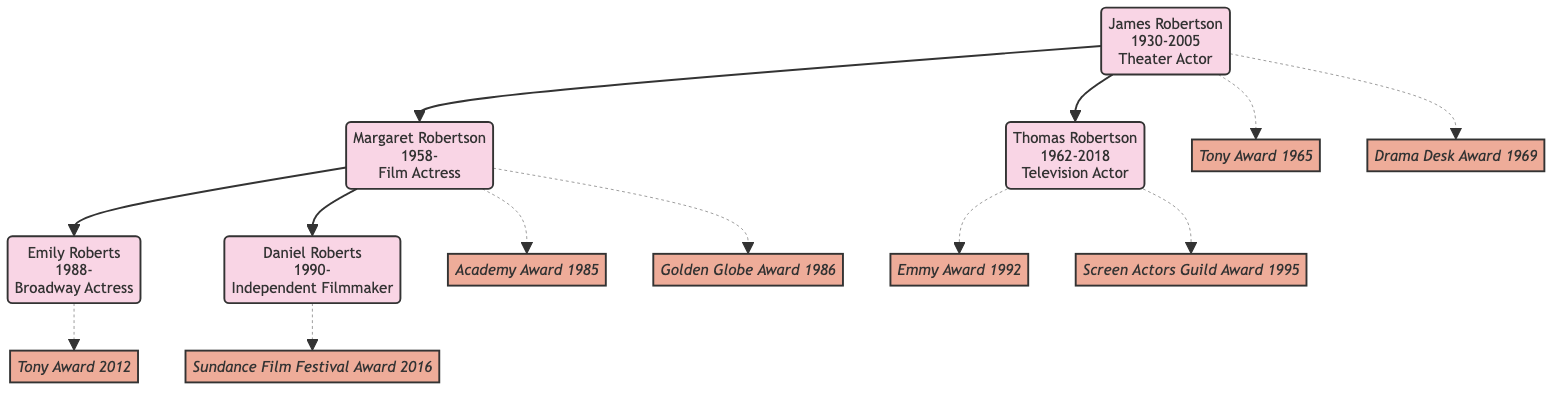What is the profession of James Robertson? The diagram shows that James Robertson is labeled as a "Theater Actor." Therefore, we look at his node to find this information directly.
Answer: Theater Actor How many children does James Robertson have? By examining the children nodes connected to James Robertson, we see there are two children: Margaret Robertson and Thomas Robertson. Thus, the count is two.
Answer: 2 What award did Thomas Robertson win in 1992? The diagram shows that Thomas Robertson won the "Emmy Award for Outstanding Lead Actor" in 1992, which is directly linked to his node as an award he received.
Answer: Emmy Award for Outstanding Lead Actor Which grandchild is a Broadway Actress? Emily Roberts' node clearly states that she is a "Broadway Actress." By locating her node among the grandchildren, we find this information directly.
Answer: Emily Roberts Who is the independent filmmaker in the family? The diagram identifies Daniel Roberts as the "Independent Filmmaker," associated with his node. Thus, he is the individual fulfilling this role in the family tree.
Answer: Daniel Roberts Which parent's performance awards are the most? We compare the number of awards listed for James Robertson, Margaret Robertson, and Thomas Robertson. James has two, Margaret has two, and Thomas also has two. Since they all tie, we conclude the number of each is equal.
Answer: Equal What year did Margaret Robertson win the Academy Award? The diagram specifies that Margaret Robertson won the "Academy Award for Best Actress" in 1985, which is noted alongside her name in the awards section.
Answer: 1985 Which performer has a connection to the Tony Award for Best Featured Actress? The diagram shows that Emily Roberts is associated with the "Tony Award for Best Featured Actress," indicated next to her name among her accomplishments. Thus, she is the linked performer.
Answer: Emily Roberts What relationships exist between James Robertson and his children? The diagram illustrates that James Robertson has direct paternal relationships with Margaret Robertson and Thomas Robertson, represented by lines connecting his node to theirs. The relationships are paternal.
Answer: Paternal 